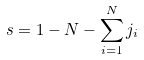<formula> <loc_0><loc_0><loc_500><loc_500>s = 1 - N - \sum _ { i = 1 } ^ { N } j _ { i }</formula> 